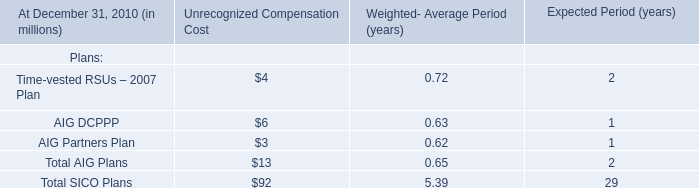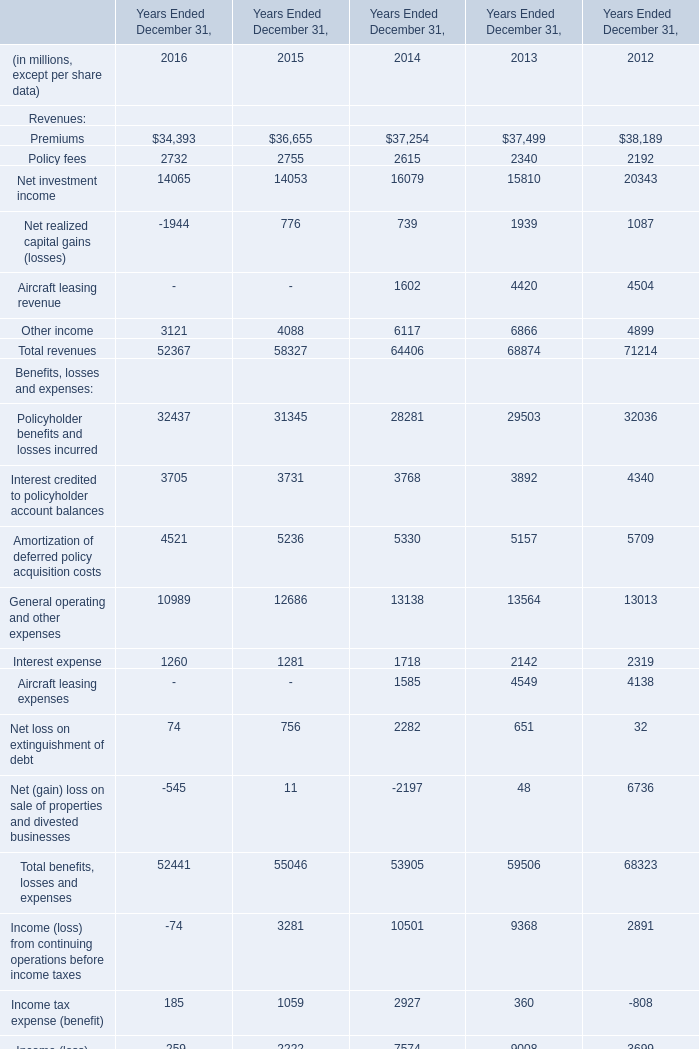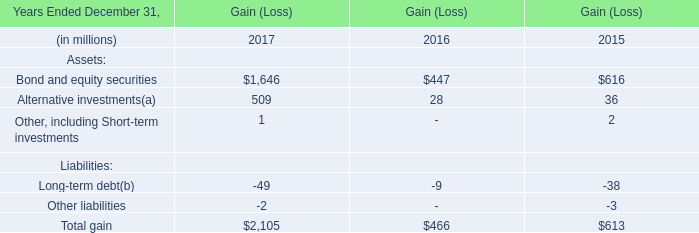In the year with largest amount of Premiums, what's the sum of Policy fees and Net investment income? (in million) 
Computations: (2192 + 20343)
Answer: 22535.0. 